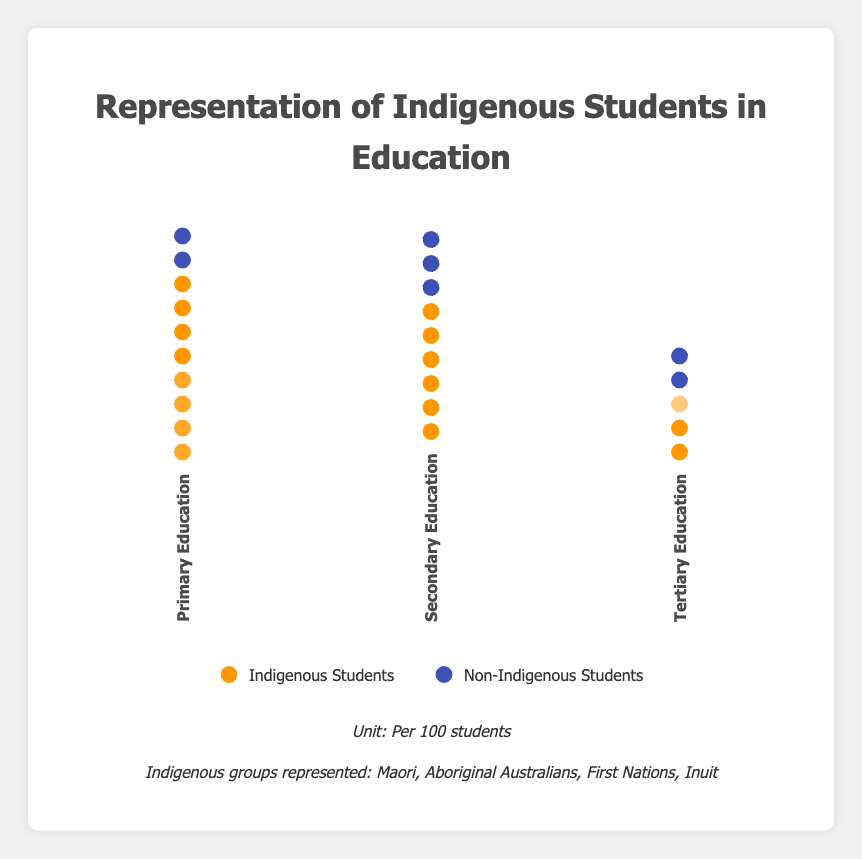What is the title of the figure? The title of a figure is typically located at the top and describes what the figure is about. Here, the title clearly reads "Representation of Indigenous Students in Education".
Answer: Representation of Indigenous Students in Education Which educational level has the highest number of indigenous students per 100? To find this, we check each bar in the isotype plot. The bar labeled "Primary Education" has the most indigenous icons, 85 in total, which is the highest among all the bars.
Answer: Primary Education How many indigenous students are represented in secondary education? We look at the bar labeled "Secondary Education" and count the indigenous student icons. There are 60 indigenous student icons.
Answer: 60 What is the ratio of indigenous to non-indigenous students in tertiary education? To find the ratio, we count the icons. For tertiary education, there are 25 indigenous students and 45 non-indigenous students. The ratio is 25:45, which can be simplified to 5:9.
Answer: 5:9 What is the difference in the number of indigenous students between primary and tertiary education? We need to subtract the number of indigenous students in tertiary education from the number in primary education. There are 85 in primary and 25 in tertiary, so the difference is 85 - 25.
Answer: 60 How does the representation of non-indigenous students change as the educational level increases? To analyze this, we observe the number of non-indigenous student icons in each educational level. Primary Education has 95, Secondary Education has 85, and Tertiary Education has 45. The number decreases as the educational level increases.
Answer: The representation decreases Compare the representation of indigenous students between primary and secondary education. We compare the number of icons for indigenous students in both levels. Primary Education has 85 indigenous students, while Secondary Education has 60. Thus, Primary Education has a higher representation.
Answer: Higher in Primary Education What percentage of students are indigenous in secondary education? First, find the total number of students, which is the sum of indigenous and non-indigenous students. For Secondary Education, this is 60 + 85 = 145. The percentage is (60/145) * 100.
Answer: ~41.38% In which educational level is the disparity between indigenous and non-indigenous students the greatest? To find the greatest disparity, we calculate the difference between indigenous and non-indigenous students for each level and compare them. The disparities are 10 for primary, 25 for secondary, and 20 for tertiary. The largest disparity is in secondary education.
Answer: Secondary Education 